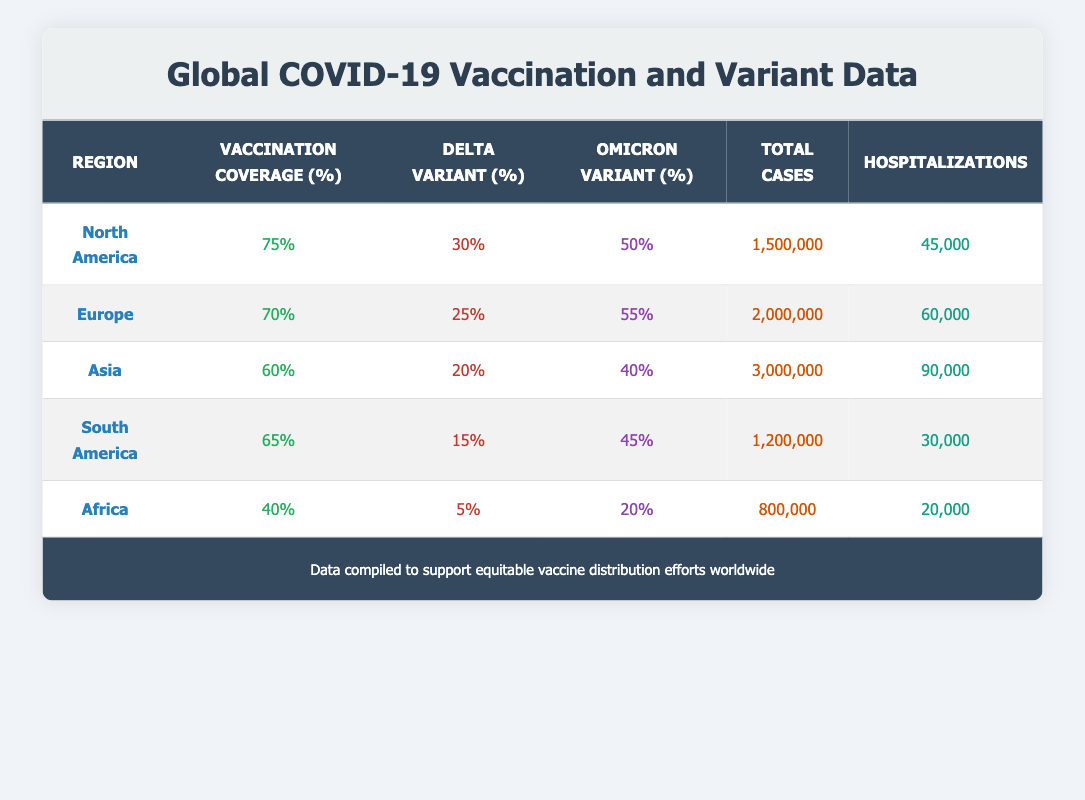What is the vaccination coverage in Asia? The table lists vaccination coverage by region, so I can directly look under the "Vaccination Coverage (%)" column for Asia, which shows 60%.
Answer: 60% Which region has the highest Delta variant prevalence? By examining the "Delta Variant (%)" column for each region, I can see that North America has the highest prevalence at 30%.
Answer: North America What is the total number of hospitalizations reported in Africa? I can directly find Africa in the "Hospitalizations" column, where it indicates 20,000 hospitalizations.
Answer: 20,000 How many total cases are there in Europe compared to South America? Looking at the "Total Cases" column, Europe has 2,000,000 total cases while South America has 1,200,000. Therefore, I find the difference: 2,000,000 - 1,200,000 = 800,000.
Answer: 800,000 Is the vaccination coverage in North America greater than in Asia? North America has a vaccination coverage of 75% while Asia has 60%. Since 75% is greater than 60%, the statement is true.
Answer: Yes What is the average vaccination coverage across all regions? I sum the vaccination coverage percentages: 75 + 70 + 60 + 65 + 40 = 310. There are 5 regions, so I divide by 5: 310/5 = 62.
Answer: 62 Which region has the lowest Omicron variant prevalence? Looking at the "Omicron Variant (%)" column for each region, the lowest prevalence is in Africa, which has 20%.
Answer: Africa If we combine the total cases from North America and Europe, how many cases do we have? I can find the total cases for both regions: North America has 1,500,000, and Europe has 2,000,000. Adding these together gives: 1,500,000 + 2,000,000 = 3,500,000.
Answer: 3,500,000 Is the Delta variant prevalence higher in Asia than in South America? Asia has a Delta variant prevalence of 20%, while South America has a prevalence of 15%. Since 20% is higher than 15%, the answer is true.
Answer: Yes 